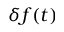<formula> <loc_0><loc_0><loc_500><loc_500>\delta f ( t )</formula> 